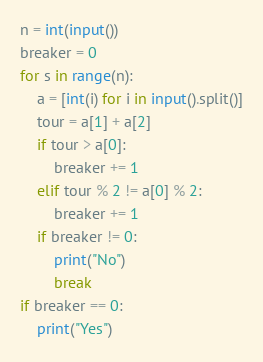Convert code to text. <code><loc_0><loc_0><loc_500><loc_500><_Python_>n = int(input())
breaker = 0
for s in range(n):
	a = [int(i) for i in input().split()]
	tour = a[1] + a[2]
	if tour > a[0]:
		breaker += 1
	elif tour % 2 != a[0] % 2:
		breaker += 1
	if breaker != 0:
		print("No")
		break
if breaker == 0:
	print("Yes")
</code> 